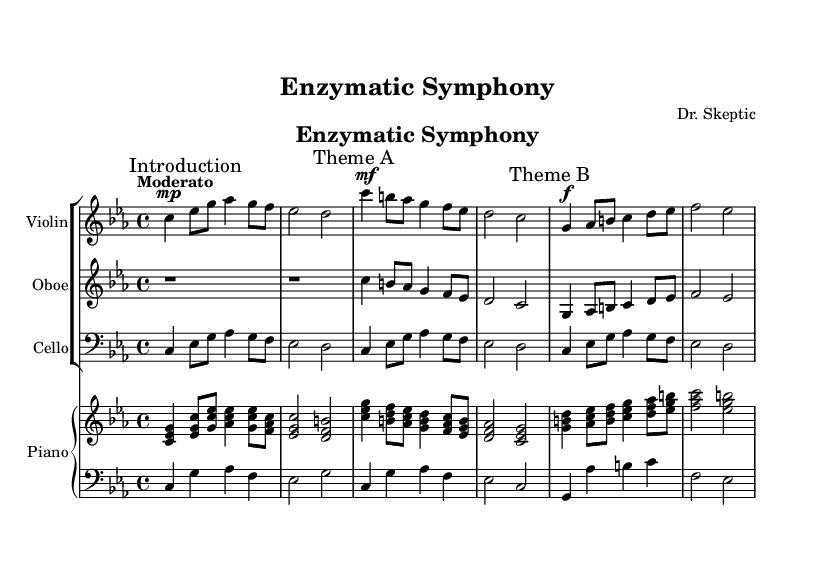What is the key signature of this music? The key signature is indicated by the symbols at the beginning of the staff. In this case, it shows four flats, which corresponds to the key of C minor.
Answer: C minor What is the time signature of the music? The time signature is shown at the beginning of the score, which specifies how many beats are in each measure. Here, it indicates 4 beats per measure, which is expressed as 4/4.
Answer: 4/4 What is the tempo marking of this composition? The tempo marking is located at the beginning of the score and gives an indication of the speed. It states "Moderato," which typically means moderately fast.
Answer: Moderato How many themes are present in the composition? To determine the number of themes, I look through the score to identify distinct sections. The score has clearly marked sections labeled "Theme A" and "Theme B," indicating that there are two themes.
Answer: 2 In which measure does Theme A begin? By scanning the score, I can locate the marked section for Theme A. It is the first theme noted and begins at the third measure of the second line. Counting measures reveals that it starts at the 5th measure overall.
Answer: 5 What dynamic marking is indicated for Theme B? Dynamic markings are indicated throughout the score, showing how loudly or softly a section should be played. For Theme B, it is marked with "f," indicating that it should be played loudly.
Answer: f What instruments are featured in this composition? The instruments are listed at the beginning of each staff. The score features a Violin, Oboe, Cello, and Piano. I can identify these by the respective titles at the beginning of each staff in the score.
Answer: Violin, Oboe, Cello, Piano 